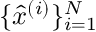<formula> <loc_0><loc_0><loc_500><loc_500>\{ \hat { x } ^ { ( i ) } \} _ { i = 1 } ^ { N }</formula> 